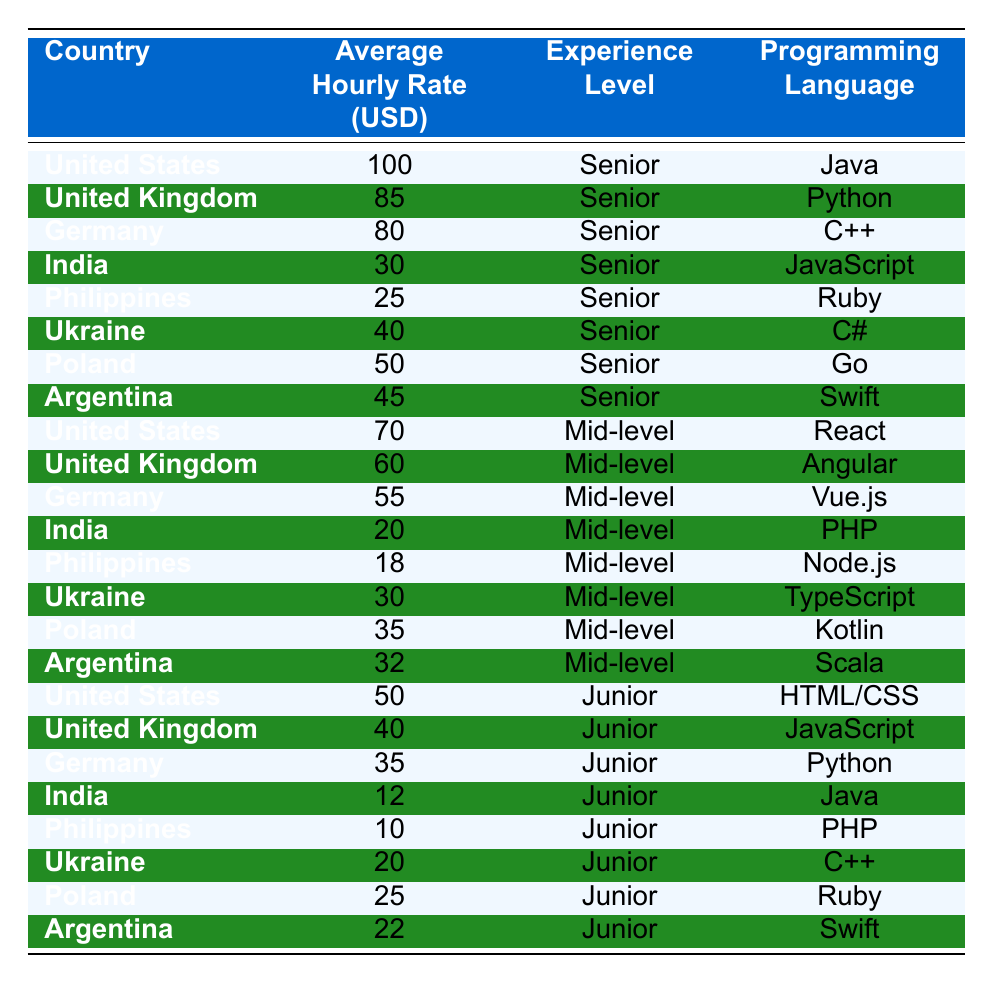What is the average hourly rate for a Senior developer in India? The table shows that the average hourly rate for a Senior developer in India is 30 USD.
Answer: 30 USD Which country has the highest hourly rate for Junior developers? By examining the Junior developer rates in the table, the United States has the highest rate at 50 USD.
Answer: United States What is the average hourly rate for Mid-level developers across all countries listed? To find the average, we sum the Mid-level rates: (70 + 60 + 55 + 20 + 18 + 30 + 35 + 32) = 300. There are 8 countries, so the average is 300/8 = 37.5 USD.
Answer: 37.5 USD Is the average hourly rate for Senior developers in the Philippines higher than that in Ukraine? The Senior hourly rate for the Philippines is 25 USD and for Ukraine is 40 USD. Since 25 < 40, the statement is false.
Answer: No What is the difference in hourly rates between Senior developers in the United States and Mid-level developers in India? The Senior rate in the United States is 100 USD and the Mid-level rate in India is 20 USD. The difference is 100 - 20 = 80 USD.
Answer: 80 USD Which programming language has the lowest average hourly rate among Junior developers? Looking at the Junior developer rates, PHP in the Philippines has the lowest rate at 10 USD.
Answer: PHP If we consider only the Senior developers, which country has the lowest hourly rate and what is it? The table indicates that the lowest hourly rate for Senior developers is in the Philippines at 25 USD.
Answer: 25 USD What is the total hourly rate for all Mid-level developers from countries in Europe (Germany, United Kingdom, Poland)? We sum the Mid-level rates from these three countries: (55 + 60 + 35) = 150 USD.
Answer: 150 USD How many countries have an hourly rate under 40 USD for Junior developers? From the Junior rates, India (12), Philippines (10), and Ukraine (20) have rates under 40 USD, totaling three countries.
Answer: 3 Is it true that the average hourly rate for a Senior developer in Argentina is above 40 USD? The Senior hourly rate in Argentina is 45 USD, which is above 40 USD, making the statement true.
Answer: Yes 